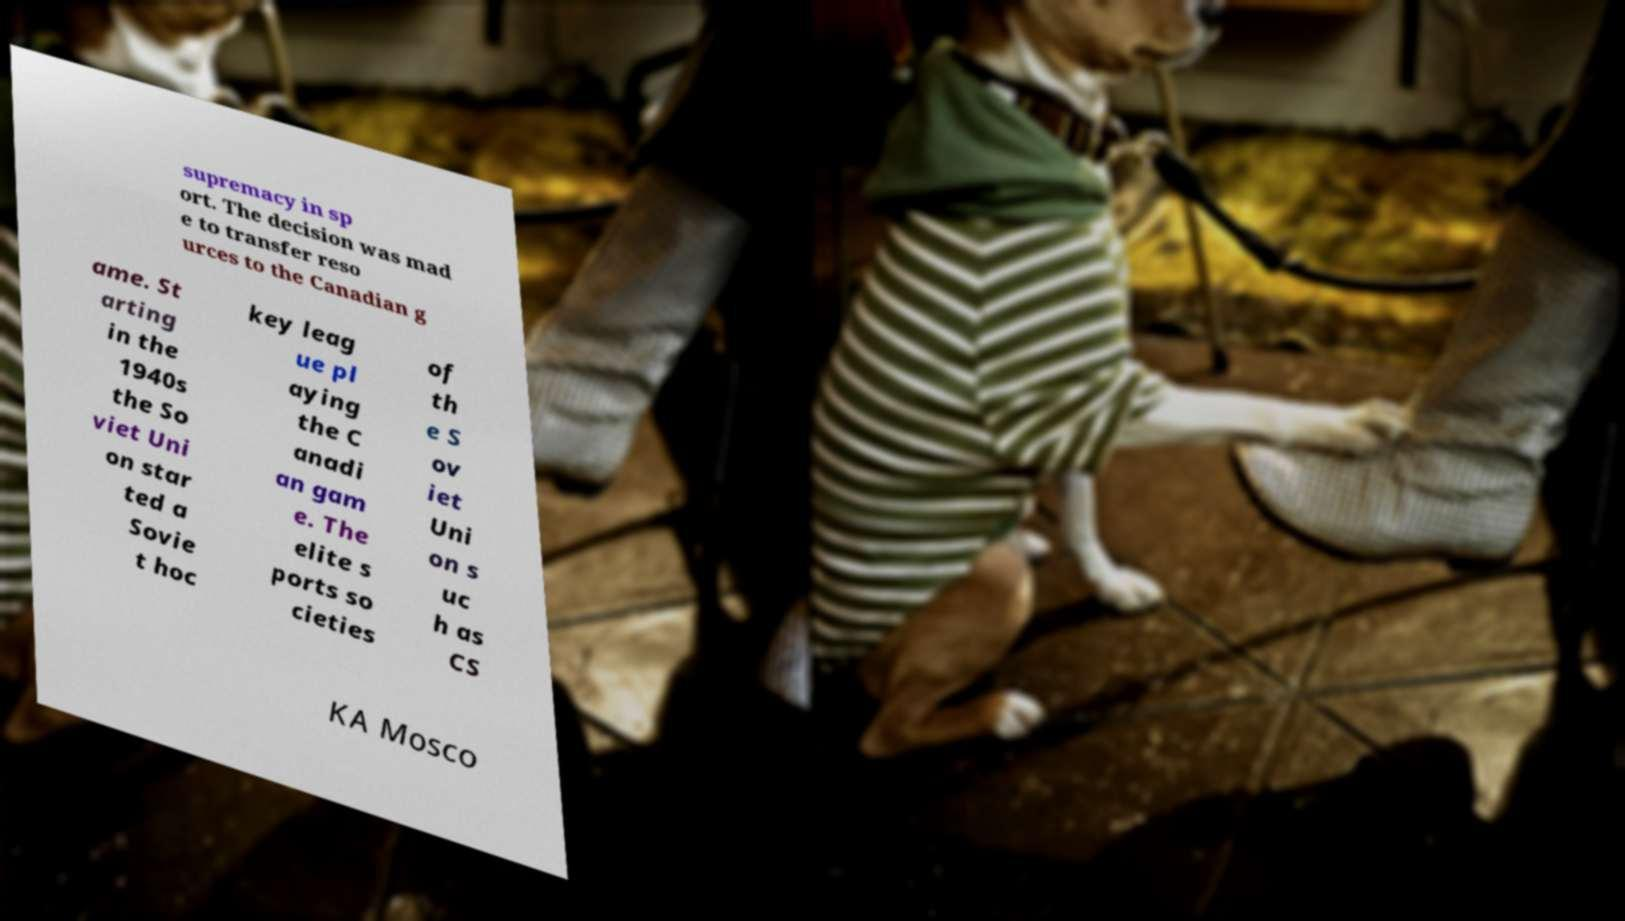For documentation purposes, I need the text within this image transcribed. Could you provide that? supremacy in sp ort. The decision was mad e to transfer reso urces to the Canadian g ame. St arting in the 1940s the So viet Uni on star ted a Sovie t hoc key leag ue pl aying the C anadi an gam e. The elite s ports so cieties of th e S ov iet Uni on s uc h as CS KA Mosco 